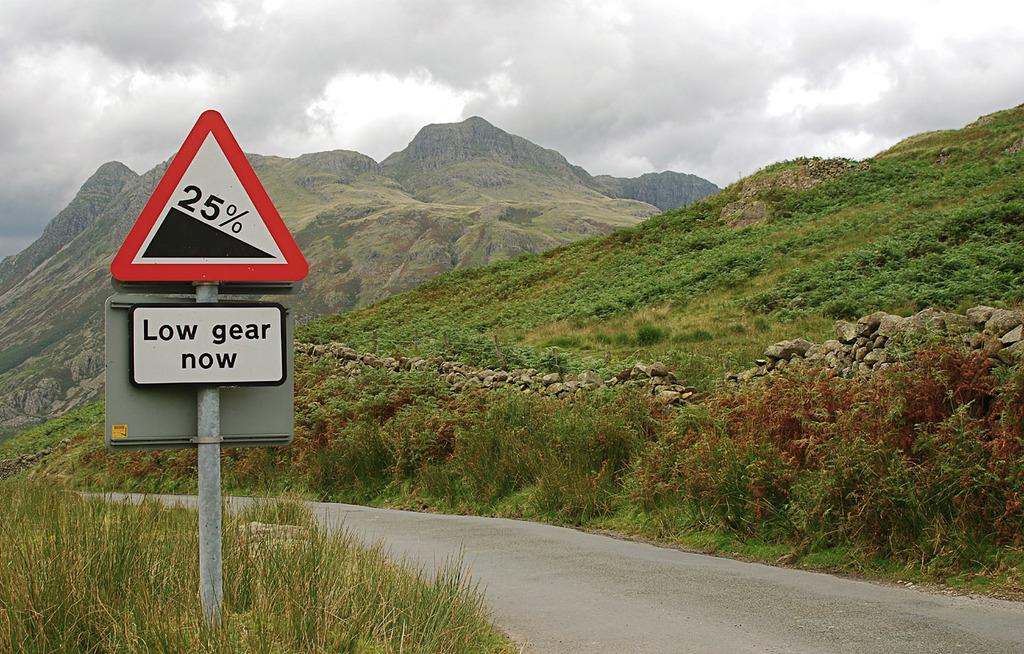<image>
Create a compact narrative representing the image presented. A sign designates a twenty five percent decline. 